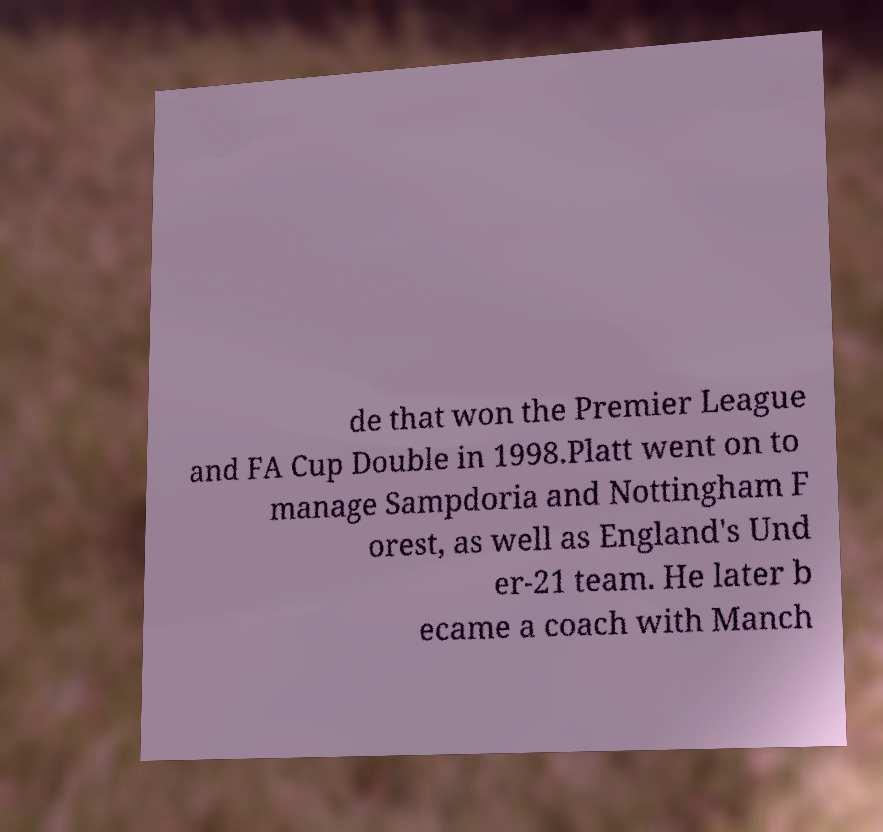For documentation purposes, I need the text within this image transcribed. Could you provide that? de that won the Premier League and FA Cup Double in 1998.Platt went on to manage Sampdoria and Nottingham F orest, as well as England's Und er-21 team. He later b ecame a coach with Manch 